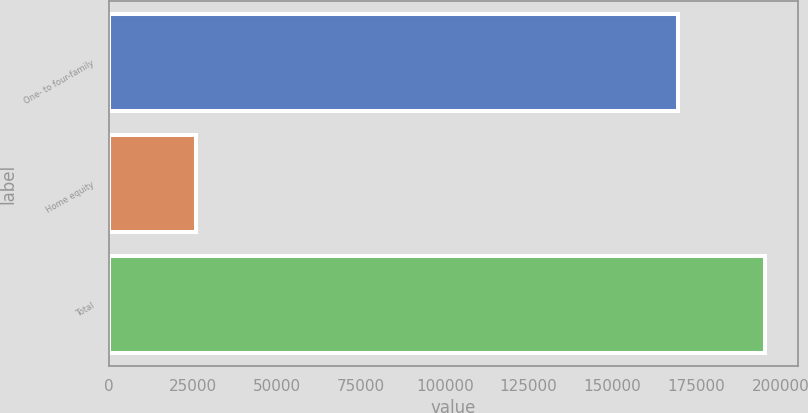<chart> <loc_0><loc_0><loc_500><loc_500><bar_chart><fcel>One- to four-family<fcel>Home equity<fcel>Total<nl><fcel>169391<fcel>26046<fcel>195437<nl></chart> 